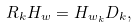Convert formula to latex. <formula><loc_0><loc_0><loc_500><loc_500>R _ { k } H _ { w } = H _ { w _ { k } } D _ { k } ,</formula> 